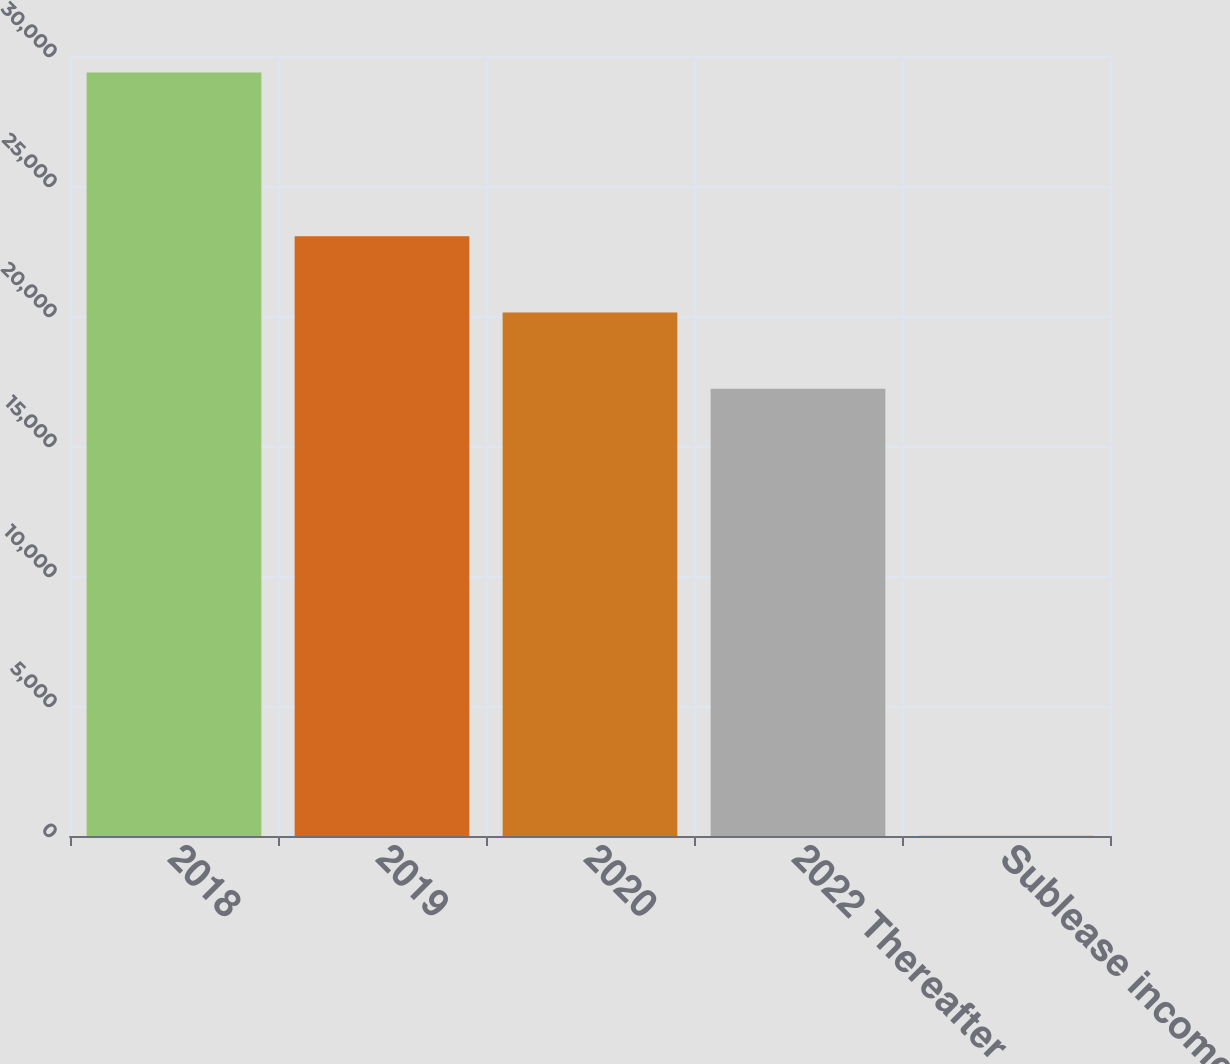Convert chart to OTSL. <chart><loc_0><loc_0><loc_500><loc_500><bar_chart><fcel>2018<fcel>2019<fcel>2020<fcel>2022 Thereafter<fcel>Sublease income<nl><fcel>29366<fcel>23069.2<fcel>20135.6<fcel>17202<fcel>30<nl></chart> 